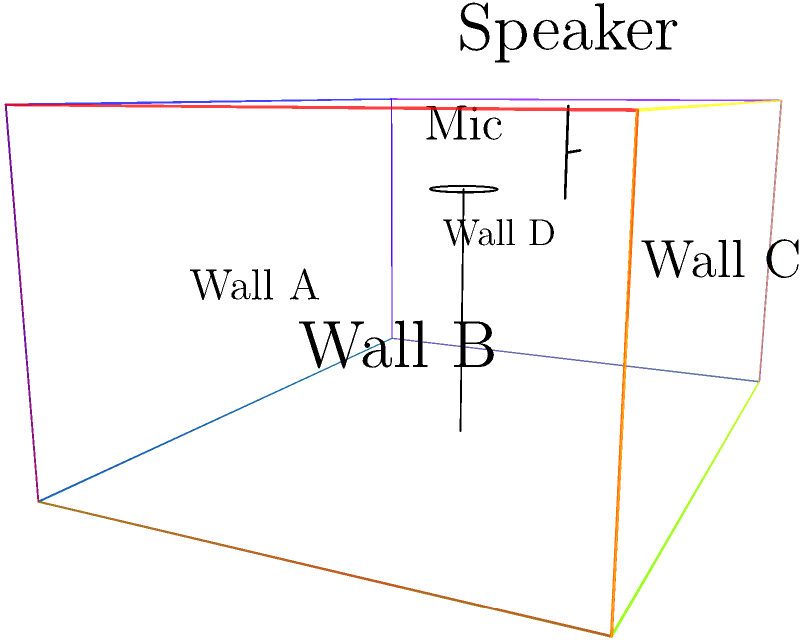In the given 3D representation of a recording studio, which wall would be most suitable for placing acoustic panels to reduce early reflections and improve the clarity of voice recordings? To determine the most suitable wall for placing acoustic panels, we need to consider the following factors:

1. Position of the microphone: The microphone is located at the center of the room, slightly elevated.

2. Early reflections: These are sound waves that reflect off nearby surfaces and reach the microphone shortly after the direct sound. They can cause phase issues and reduce clarity.

3. Wall proximity: The closer a wall is to the microphone, the more likely it is to cause early reflections.

4. Wall size: Larger walls provide more surface area for reflections.

Analyzing the walls:

- Wall A (front): Close to the microphone, but not directly facing it.
- Wall B (right): Further from the microphone, less likely to cause significant early reflections.
- Wall C (back): Furthest from the microphone, least likely to cause early reflections.
- Wall D (left): Close to the microphone and directly facing it.

Wall D is the most critical surface for early reflections because:
1. It's close to the microphone.
2. It's directly facing the microphone.
3. Sound waves will bounce off this wall and quickly reach the microphone.

By placing acoustic panels on Wall D, we can effectively reduce early reflections and improve the clarity of voice recordings.
Answer: Wall D 